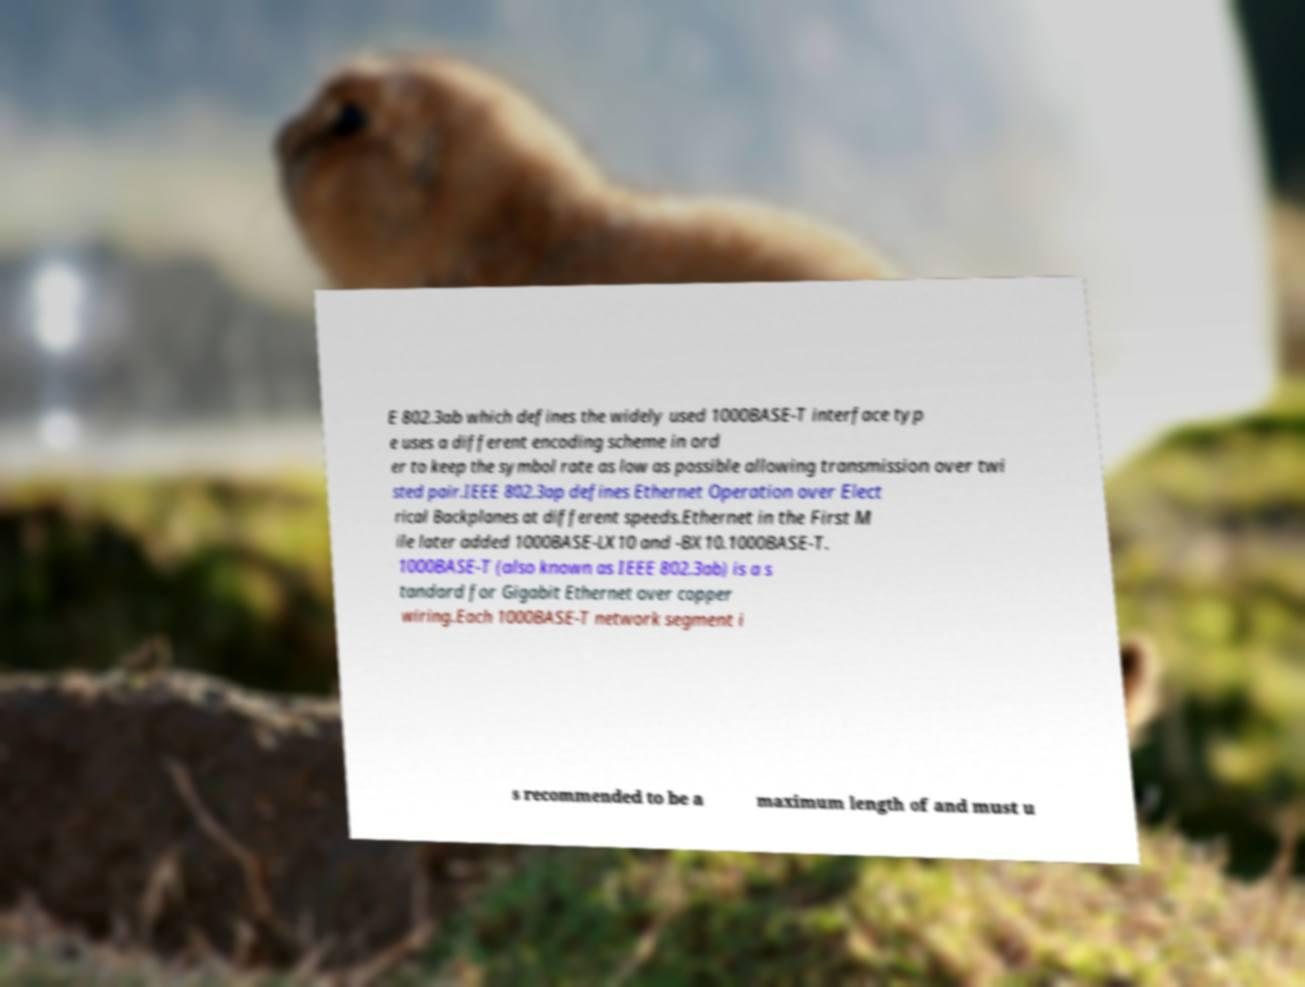Please identify and transcribe the text found in this image. E 802.3ab which defines the widely used 1000BASE-T interface typ e uses a different encoding scheme in ord er to keep the symbol rate as low as possible allowing transmission over twi sted pair.IEEE 802.3ap defines Ethernet Operation over Elect rical Backplanes at different speeds.Ethernet in the First M ile later added 1000BASE-LX10 and -BX10.1000BASE-T. 1000BASE-T (also known as IEEE 802.3ab) is a s tandard for Gigabit Ethernet over copper wiring.Each 1000BASE-T network segment i s recommended to be a maximum length of and must u 